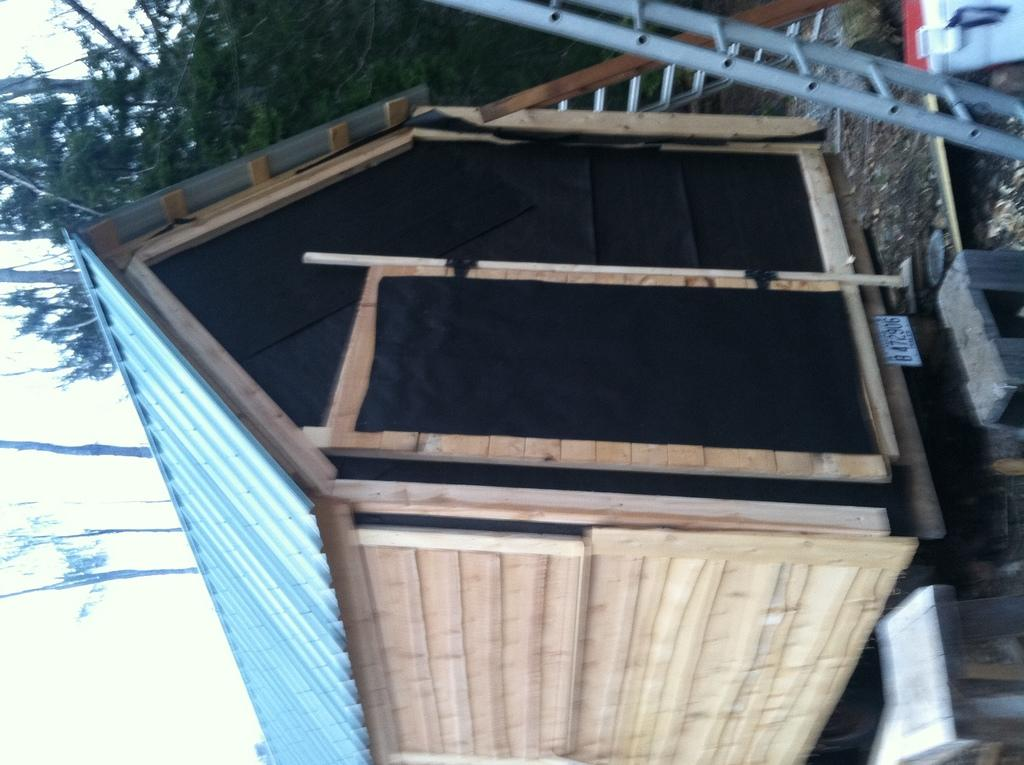What type of structure is present in the image? There is a small wooden shed in the image. What is located in front of the shed? There is a silver ladder in front of the shed. What can be seen behind the shed? There are trees visible behind the shed. What type of waste can be seen accumulating near the shed in the image? There is no waste visible in the image; it only shows a small wooden shed, a silver ladder, and trees in the background. 